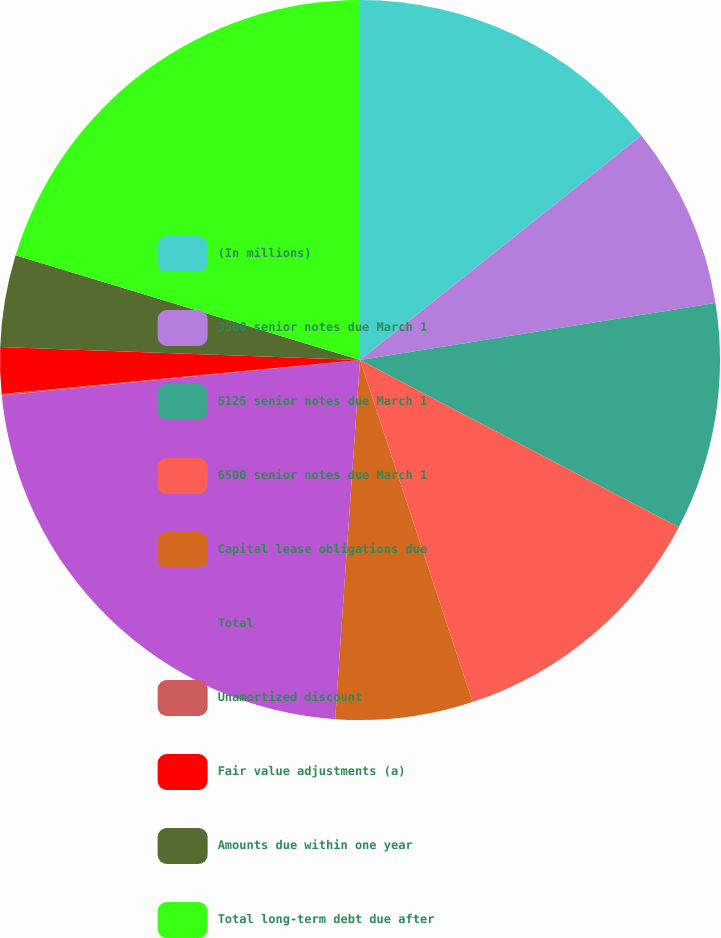<chart> <loc_0><loc_0><loc_500><loc_500><pie_chart><fcel>(In millions)<fcel>3500 senior notes due March 1<fcel>5125 senior notes due March 1<fcel>6500 senior notes due March 1<fcel>Capital lease obligations due<fcel>Total<fcel>Unamortized discount<fcel>Fair value adjustments (a)<fcel>Amounts due within one year<fcel>Total long-term debt due after<nl><fcel>14.28%<fcel>8.19%<fcel>10.22%<fcel>12.25%<fcel>6.16%<fcel>22.33%<fcel>0.06%<fcel>2.09%<fcel>4.12%<fcel>20.3%<nl></chart> 